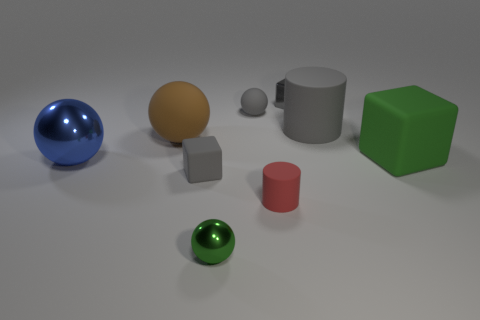Subtract all red spheres. Subtract all yellow blocks. How many spheres are left? 4 Add 1 big matte spheres. How many objects exist? 10 Subtract all balls. How many objects are left? 5 Subtract all green shiny things. Subtract all small metallic blocks. How many objects are left? 7 Add 5 cubes. How many cubes are left? 8 Add 5 tiny red objects. How many tiny red objects exist? 6 Subtract 1 blue balls. How many objects are left? 8 